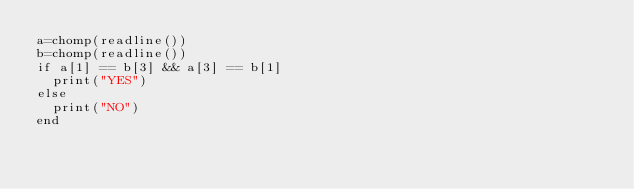<code> <loc_0><loc_0><loc_500><loc_500><_Julia_>a=chomp(readline())
b=chomp(readline())
if a[1] == b[3] && a[3] == b[1]
  print("YES")
else
  print("NO")
end</code> 